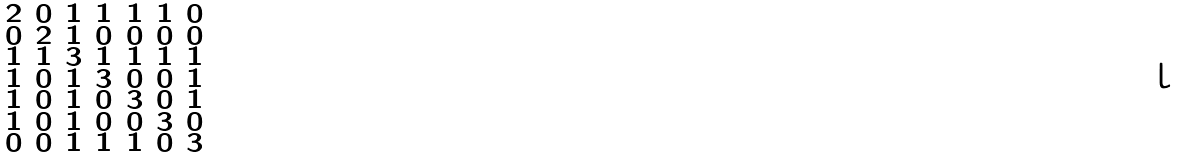<formula> <loc_0><loc_0><loc_500><loc_500>\begin{smallmatrix} 2 & 0 & 1 & 1 & 1 & 1 & 0 \\ 0 & 2 & 1 & 0 & 0 & 0 & 0 \\ 1 & 1 & 3 & 1 & 1 & 1 & 1 \\ 1 & 0 & 1 & 3 & 0 & 0 & 1 \\ 1 & 0 & 1 & 0 & 3 & 0 & 1 \\ 1 & 0 & 1 & 0 & 0 & 3 & 0 \\ 0 & 0 & 1 & 1 & 1 & 0 & 3 \end{smallmatrix}</formula> 